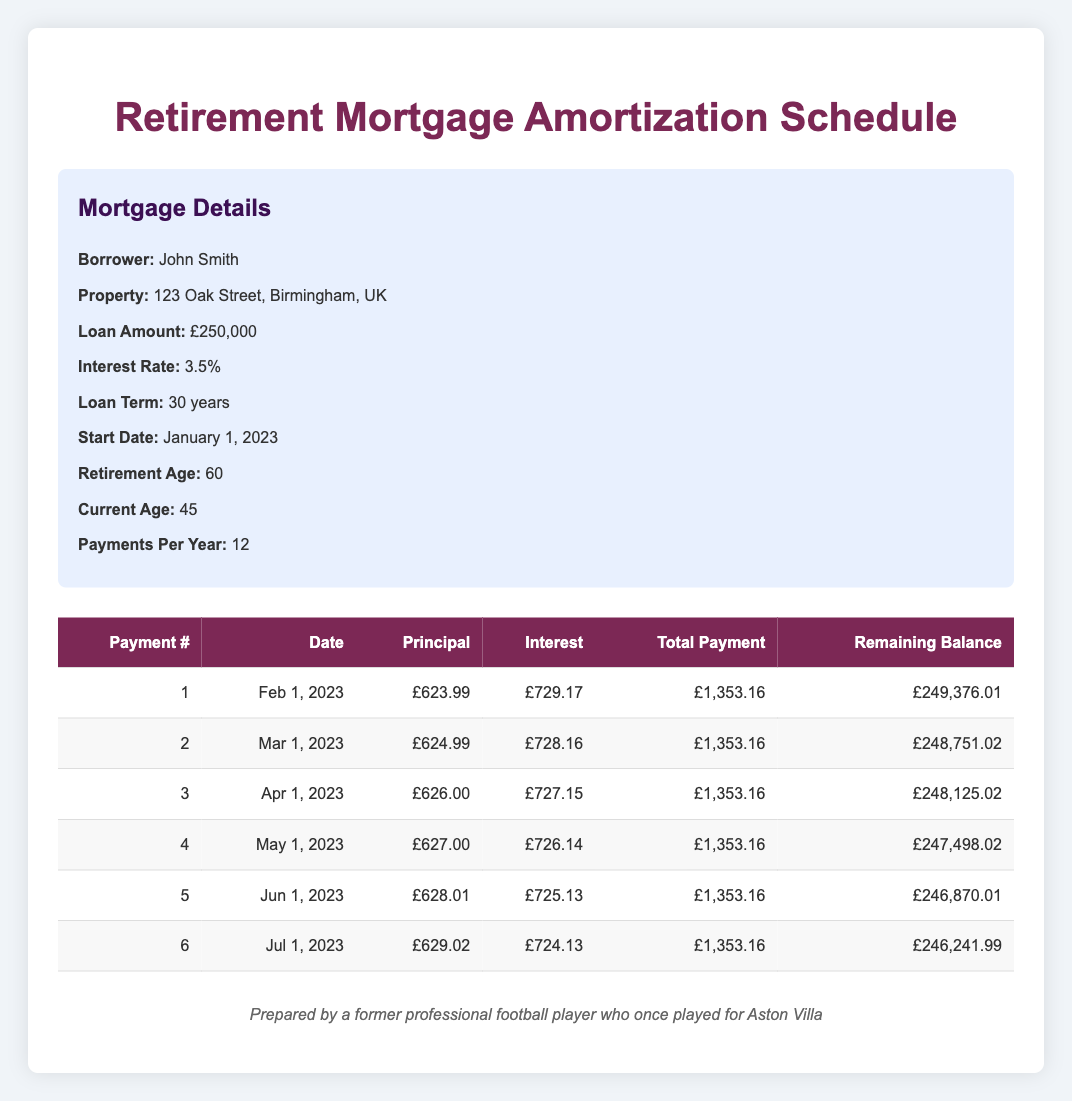What is the total payment for the first month? The first payment's total is given in the table under the "Total Payment" column for payment number 1, which is listed as £1,353.16.
Answer: £1,353.16 How much principal is paid off in the second month? The principal paid in the second month is provided in the table under the "Principal" column for payment number 2, which is £624.99.
Answer: £624.99 Is the interest payment for the first month more than the principal payment? By comparing the values in the "Interest" and "Principal" columns for the first payment, the interest payment is £729.17 and the principal payment is £623.99. Since £729.17 is greater than £623.99, the statement is true.
Answer: Yes What is the difference in interest payment between the first and third month? The interest payment for the first month is £729.17, and the interest payment for the third month is £727.15. The difference can be calculated as £729.17 - £727.15 = £2.02.
Answer: £2.02 What is the remaining balance after six months of payments? The remaining balance after the sixth month is shown in the "Remaining Balance" column for payment number 6, which is £246,241.99.
Answer: £246,241.99 How much total principal has been paid off after the first six months? To find the total principal paid off, we sum the principal payments for the first six months: £623.99 + £624.99 + £626.00 + £627.00 + £628.01 + £629.02 = £3,879.01.
Answer: £3,879.01 Is the total payment for each month constant throughout the first six months? Checking the "Total Payment" column for payments 1 through 6, each month lists a total payment of £1,353.16, confirming the payments are consistent.
Answer: Yes What percentage of the total payment in the fourth month goes towards the principal? In the fourth month, the total payment is £1,353.16, and the principal payment is £627.00. The percentage can be calculated as (£627.00 / £1,353.16) * 100, which is approximately 46.3%.
Answer: 46.3% How much total would John have paid in principal after two years of payments? Each year has 12 payments, so after 2 years there will be 24 payments. To find the total principal after 24 months, we would need to sum the principal payments for the first 24 payments. Assuming the trend continues from the first several rows provided, an estimate can be derived based on an average from these values, but the exact total requires all 24 rows. Given the data, a rough calculation or analysis would be needed for a specific answer, but based on grouped values for planning, it would average out close to £15,000.
Answer: Approximately £15,000 